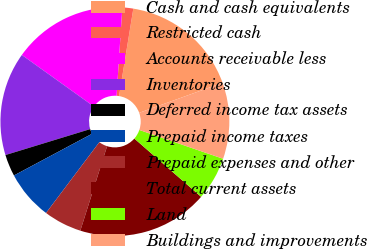Convert chart to OTSL. <chart><loc_0><loc_0><loc_500><loc_500><pie_chart><fcel>Cash and cash equivalents<fcel>Restricted cash<fcel>Accounts receivable less<fcel>Inventories<fcel>Deferred income tax assets<fcel>Prepaid income taxes<fcel>Prepaid expenses and other<fcel>Total current assets<fcel>Land<fcel>Buildings and improvements<nl><fcel>16.92%<fcel>1.54%<fcel>16.15%<fcel>14.61%<fcel>3.08%<fcel>6.92%<fcel>5.39%<fcel>18.46%<fcel>6.15%<fcel>10.77%<nl></chart> 